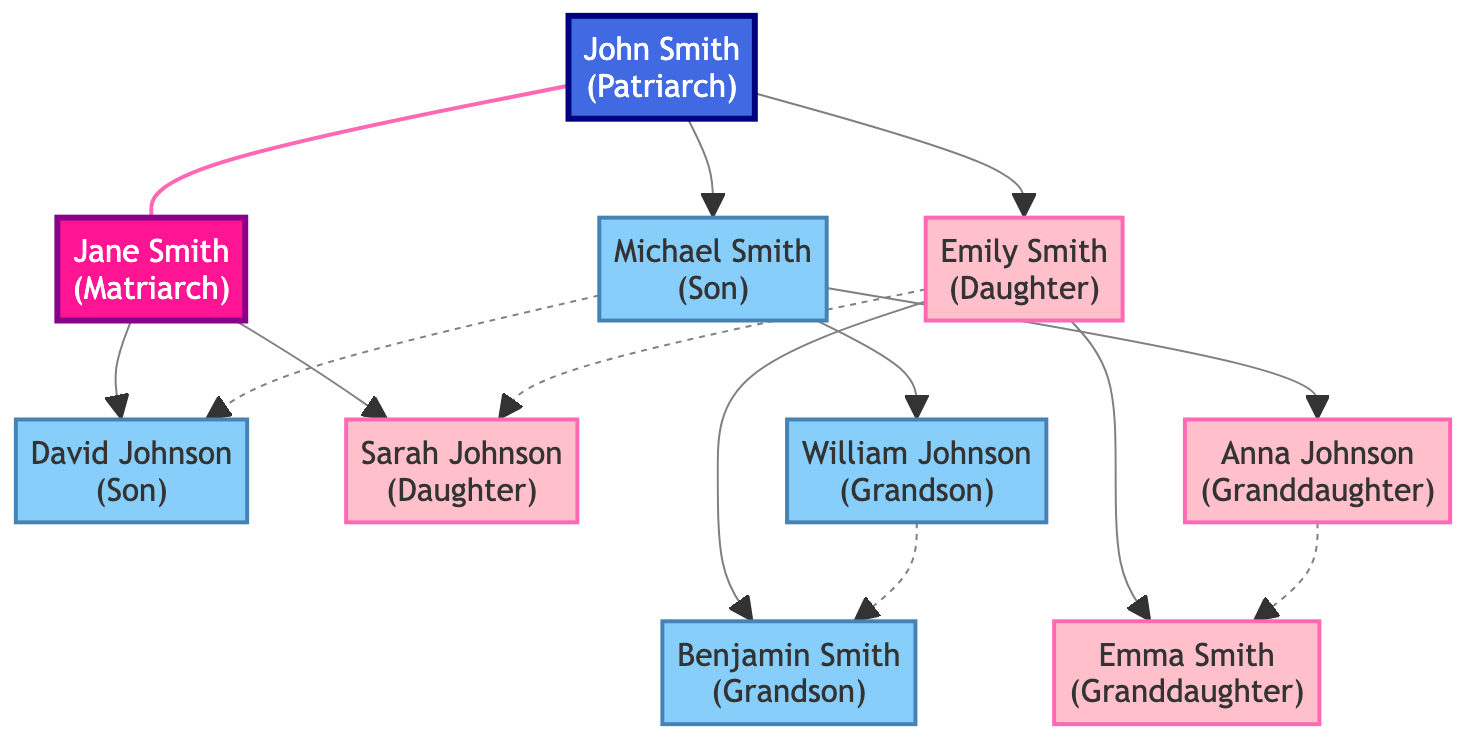What is the role of the top individual in the diagram? The top individual is John Smith, who is labeled as the patriarch, indicating his primary role in the family lineage.
Answer: patriarch How many grandchildren are there in the family tree? There are four grandchildren: William Johnson, Anna Johnson, Benjamin Smith, and Emma Smith. This can be observed by counting the individuals in the third generation (nodes with generation 3).
Answer: 4 What is the relationship between Michael Smith and David Johnson? Michael Smith is a cousin to David Johnson, indicated by a dashed line connecting nodes 3 and 5, which depicts a cousin relationship.
Answer: cousin Which individual is Jane Smith's child? Jane Smith has two children: David Johnson and Sarah Johnson, as shown in the second generation connected to her node.
Answer: David Johnson and Sarah Johnson Who are the sons in the family tree? The sons in the family tree are Michael Smith and David Johnson, who can be identified from their respective roles as listed in the diagram.
Answer: Michael Smith, David Johnson How many female individuals are in the second generation? There are two female individuals in the second generation: Emily Smith and Sarah Johnson, noted in the diagram as children of John Smith and Jane Smith.
Answer: 2 Which individual is a grandson of John Smith? William Johnson and Benjamin Smith are both grandsons of John Smith, as they are children of Michael Smith and Emily Smith, respectively.
Answer: William Johnson, Benjamin Smith Who is the only matriarch in the family tree? The only matriarch in the family tree is Jane Smith, as identified by her unique label and role at the top of the lineage.
Answer: Jane Smith 